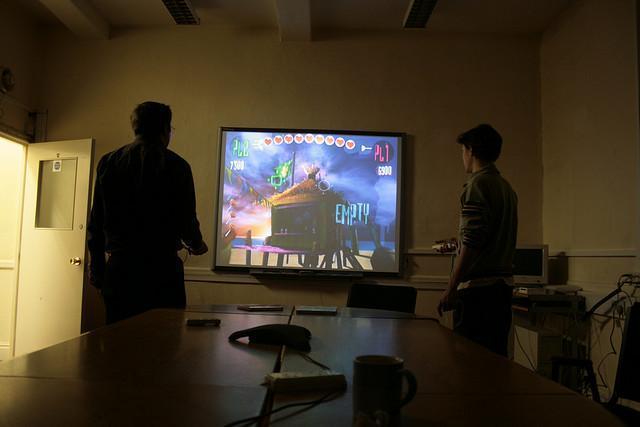How many people are watching the TV?
Give a very brief answer. 2. How many cups are in the picture?
Give a very brief answer. 1. How many people are in the photo?
Give a very brief answer. 2. How many double decker buses are in this scene?
Give a very brief answer. 0. 